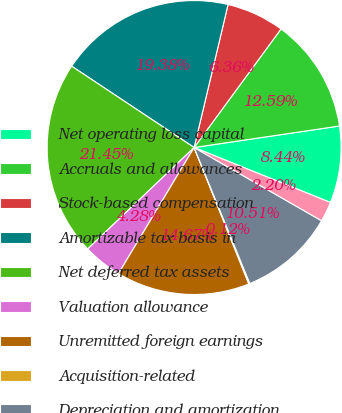Convert chart to OTSL. <chart><loc_0><loc_0><loc_500><loc_500><pie_chart><fcel>Net operating loss capital<fcel>Accruals and allowances<fcel>Stock-based compensation<fcel>Amortizable tax basis in<fcel>Net deferred tax assets<fcel>Valuation allowance<fcel>Unremitted foreign earnings<fcel>Acquisition-related<fcel>Depreciation and amortization<fcel>Available-for-sale securities<nl><fcel>8.44%<fcel>12.59%<fcel>6.36%<fcel>19.38%<fcel>21.45%<fcel>4.28%<fcel>14.67%<fcel>0.12%<fcel>10.51%<fcel>2.2%<nl></chart> 